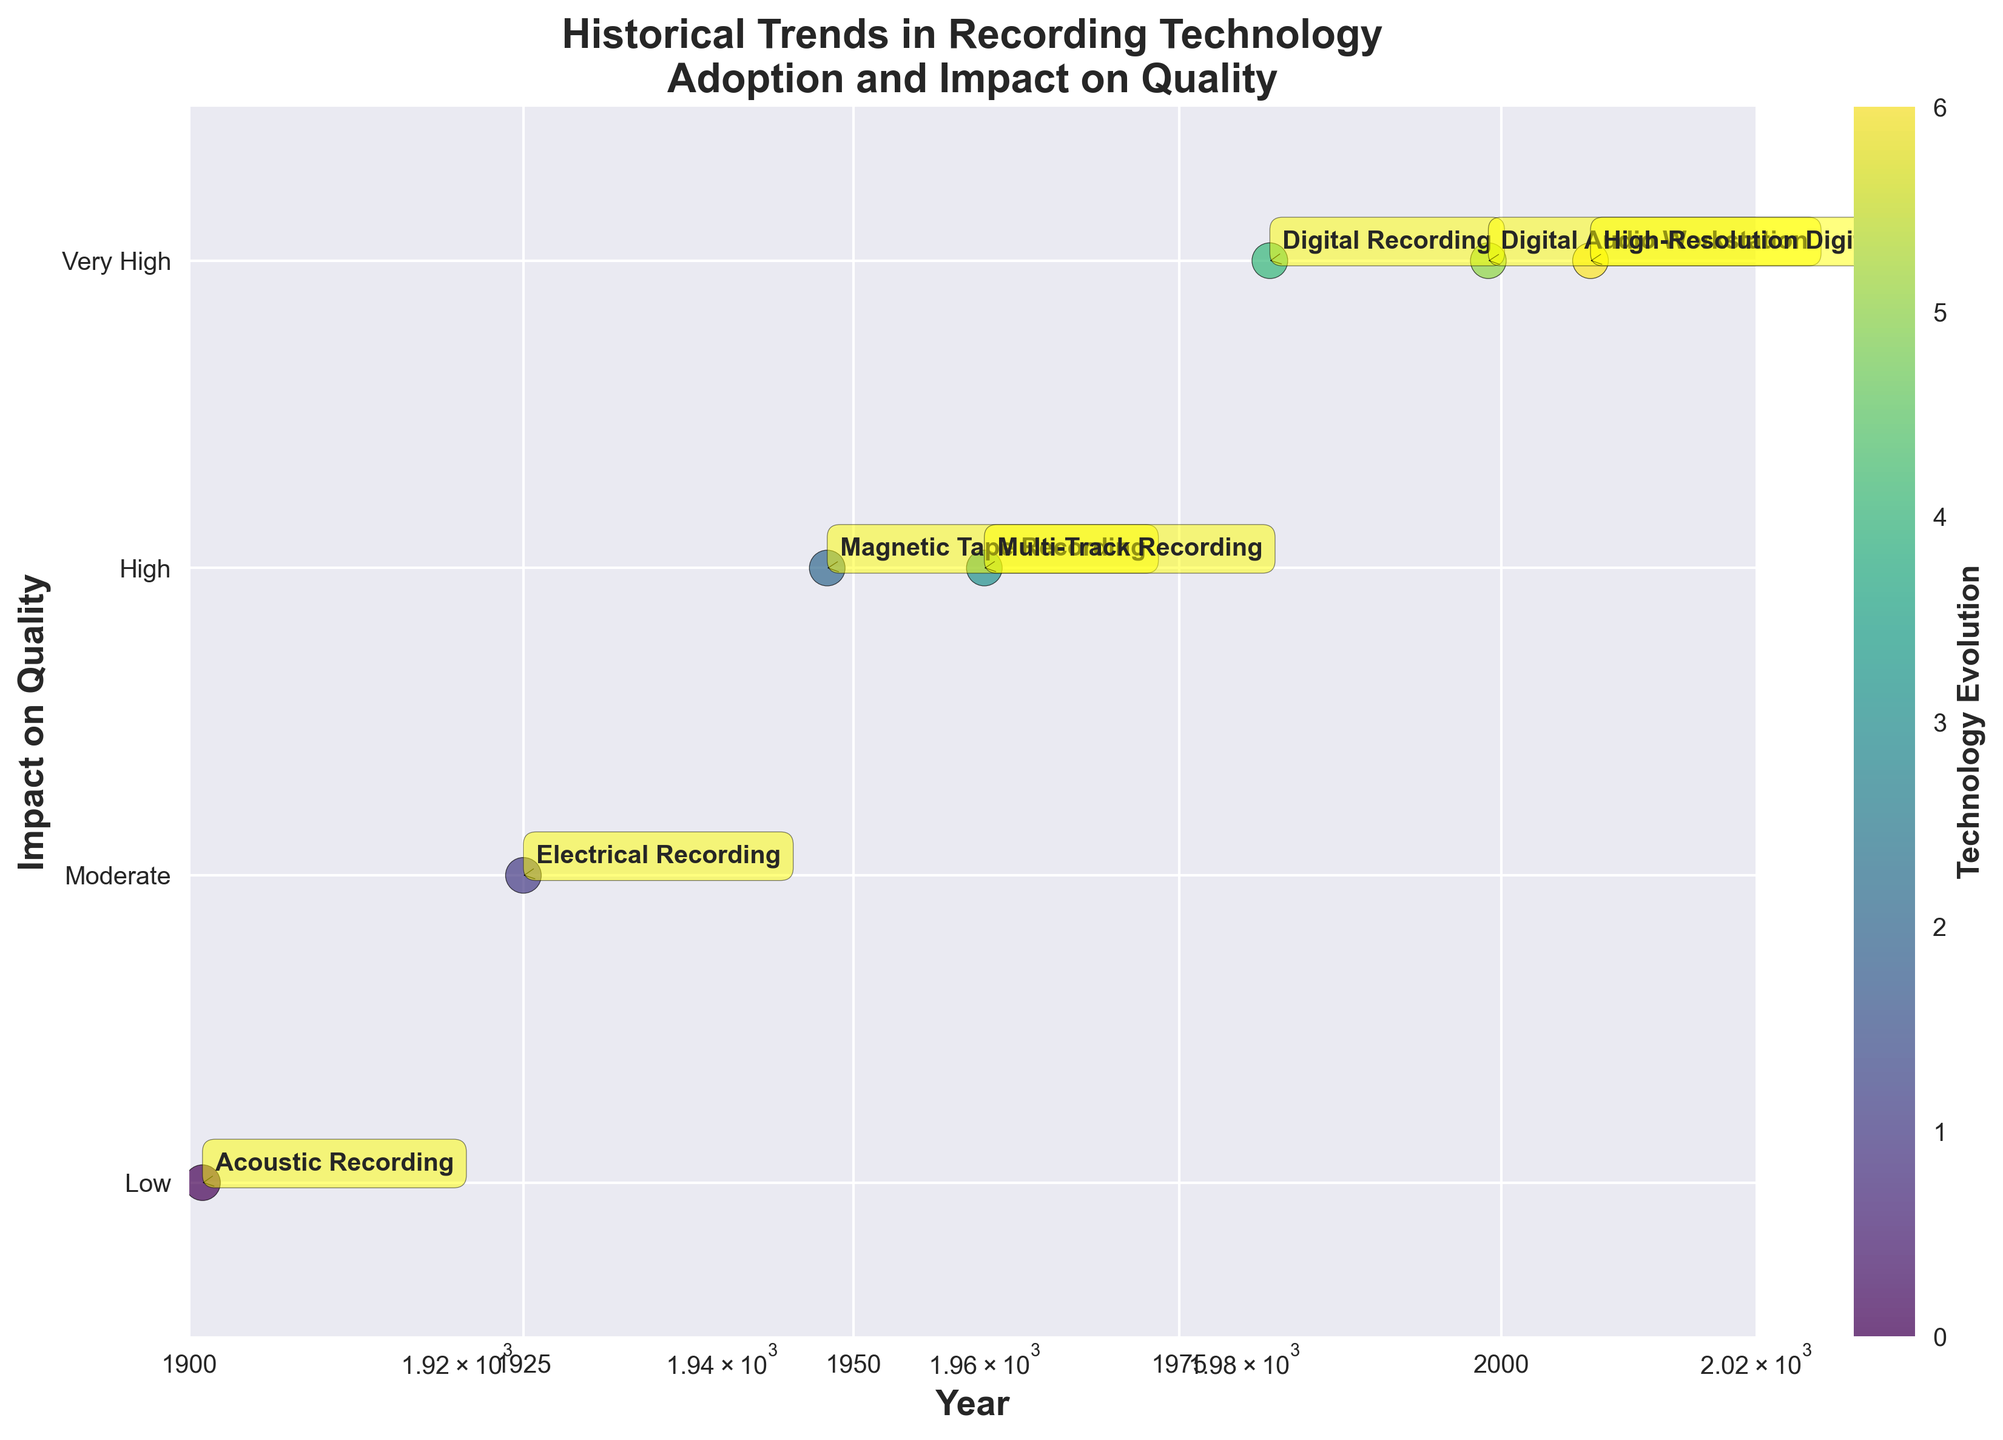What is the title of the scatter plot? The main title can be found at the top of the plot. The title here is "Historical Trends in Recording Technology\nAdoption and Impact on Quality".
Answer: Historical Trends in Recording Technology Adoption and Impact on Quality What are the labels on the x and y axes? The label on the x-axis can be found at the bottom, and the label on the y-axis can be found on the left side of the plot. The x-axis is labeled "Year", and the y-axis is labeled "Impact on Quality".
Answer: Year and Impact on Quality Which technology corresponds to the year 1982 and what is its impact on quality? In the scatter plot, find the point labeled with "1982". The label next to it will indicate the corresponding technology and its impact on quality. The label for 1982 shows "Digital Recording" with an impact on quality of "Very High".
Answer: Digital Recording and Very High How many technologies are represented in the plot? Count the number of distinct data points annotated with technology names in the scatter plot. There are seven annotated points.
Answer: Seven What is the difference in quality impact between Acoustic Recording and Digital Recording? Find the y-axis positions of "Acoustic Recording" and "Digital Recording". "Acoustic Recording" is at the "Low" position (1), and "Digital Recording" is at the "Very High" position (4). The difference in quality impact is 4 - 1 = 3.
Answer: 3 Which technology shows up after 1925 and has the highest impact on quality? Identify points on the plot that occur after 1925 which also have the highest y-axis value labeled "Very High". The point at "1982" with "Digital Recording", "1999" with "Digital Audio Workstation", and "2007" with "High-Resolution Digital" are "Very High". The one appearing first in this list is "Digital Recording".
Answer: Digital Recording By how many years did the adoption of Magnetic Tape Recording trail behind Electrical Recording? Identify the x-axis positions for "Magnetic Tape Recording" and "Electrical Recording". "Magnetic Tape Recording" is at 1948, and "Electrical Recording" is at 1925. The difference is 1948 - 1925 = 23 years.
Answer: 23 years What is the scale of the x-axis and what does it imply? The x-axis is labeled "Year" and is set to a log scale as indicated by the logarithmic spacing of tick marks. This implies the data points represent exponentially growing trends over time.
Answer: Logarithmic, exponential trends Which recording technology adopted between 1940 and 1950 had a "High" impact on quality? Find the technology point within the 1940 to 1950 range on the x-axis and check the y-axis impact labeled "High". This point is "Magnetic Tape Recording" in 1948 with a "High" impact on quality.
Answer: Magnetic Tape Recording 